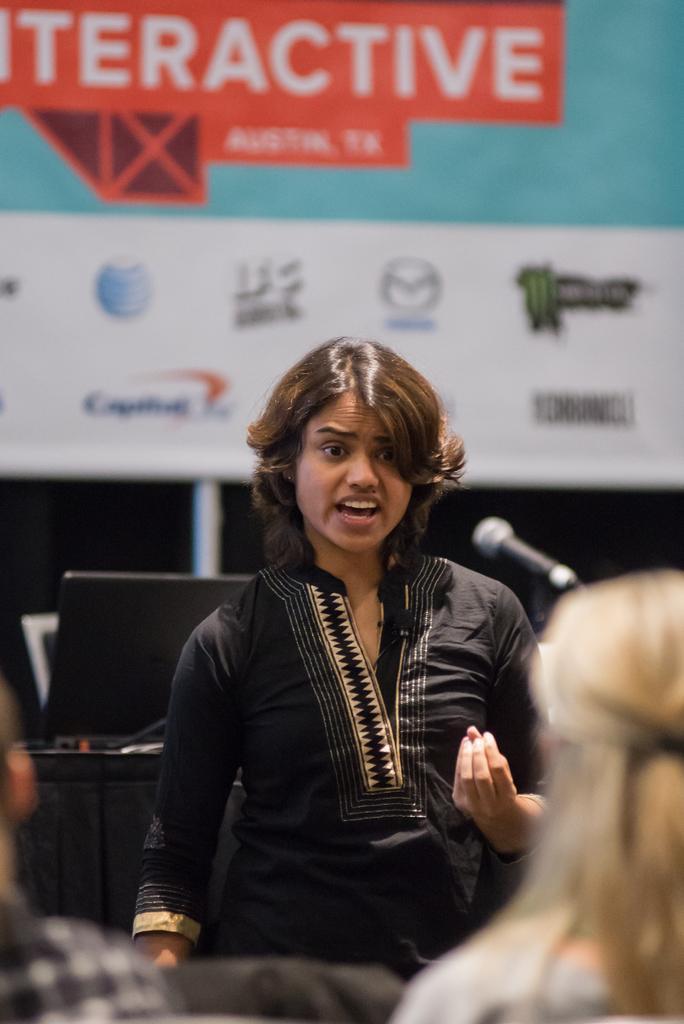How would you summarize this image in a sentence or two? In this image, we can see a woman in black dress is talking in-front of a microphone. At the bottom, we can see few people. Background we can see laptop, black cloth, banner and rod. 